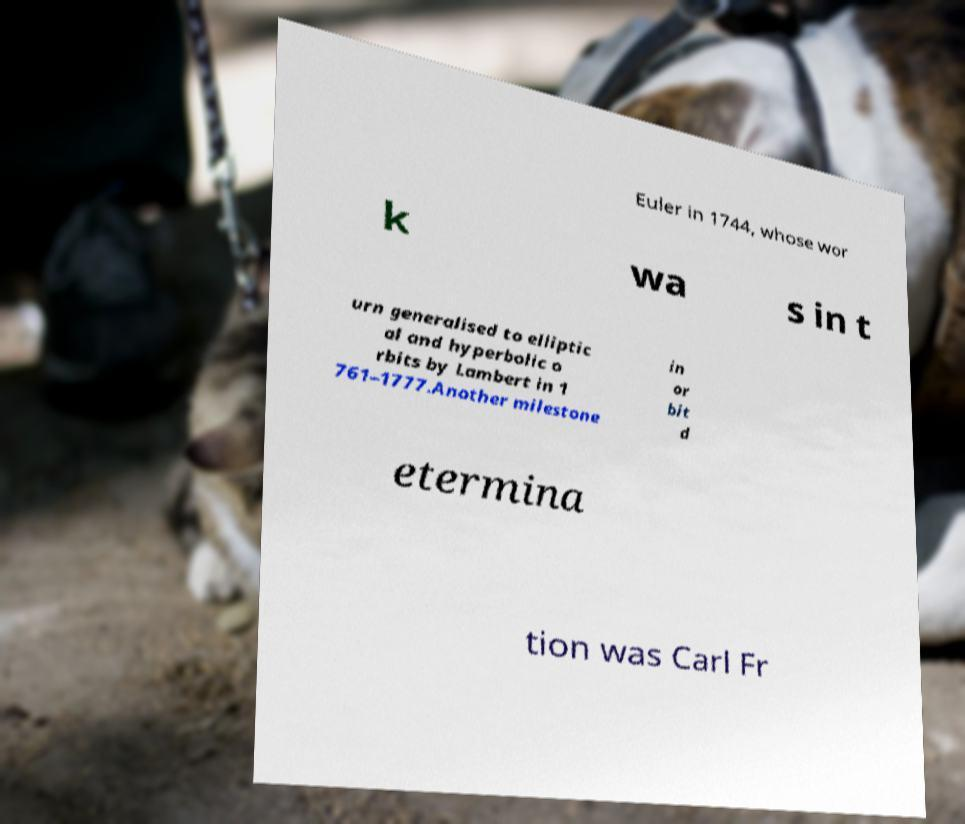Could you extract and type out the text from this image? Euler in 1744, whose wor k wa s in t urn generalised to elliptic al and hyperbolic o rbits by Lambert in 1 761–1777.Another milestone in or bit d etermina tion was Carl Fr 